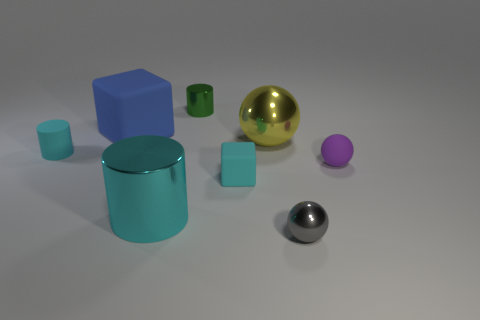What size is the matte cylinder that is the same color as the small block?
Your answer should be very brief. Small. Is there a shiny cube that has the same color as the large cylinder?
Keep it short and to the point. No. What color is the rubber sphere that is the same size as the cyan cube?
Ensure brevity in your answer.  Purple. There is a rubber object right of the small gray thing; how many small green shiny objects are on the right side of it?
Ensure brevity in your answer.  0. How many things are tiny matte blocks that are left of the big yellow thing or red cubes?
Offer a terse response. 1. How many blue blocks are the same material as the tiny gray sphere?
Provide a short and direct response. 0. The big thing that is the same color as the rubber cylinder is what shape?
Offer a very short reply. Cylinder. Are there the same number of large blue rubber things that are right of the gray thing and tiny gray shiny cylinders?
Provide a short and direct response. Yes. What is the size of the cyan object that is behind the small rubber ball?
Ensure brevity in your answer.  Small. What number of tiny objects are matte objects or yellow matte blocks?
Offer a very short reply. 3. 